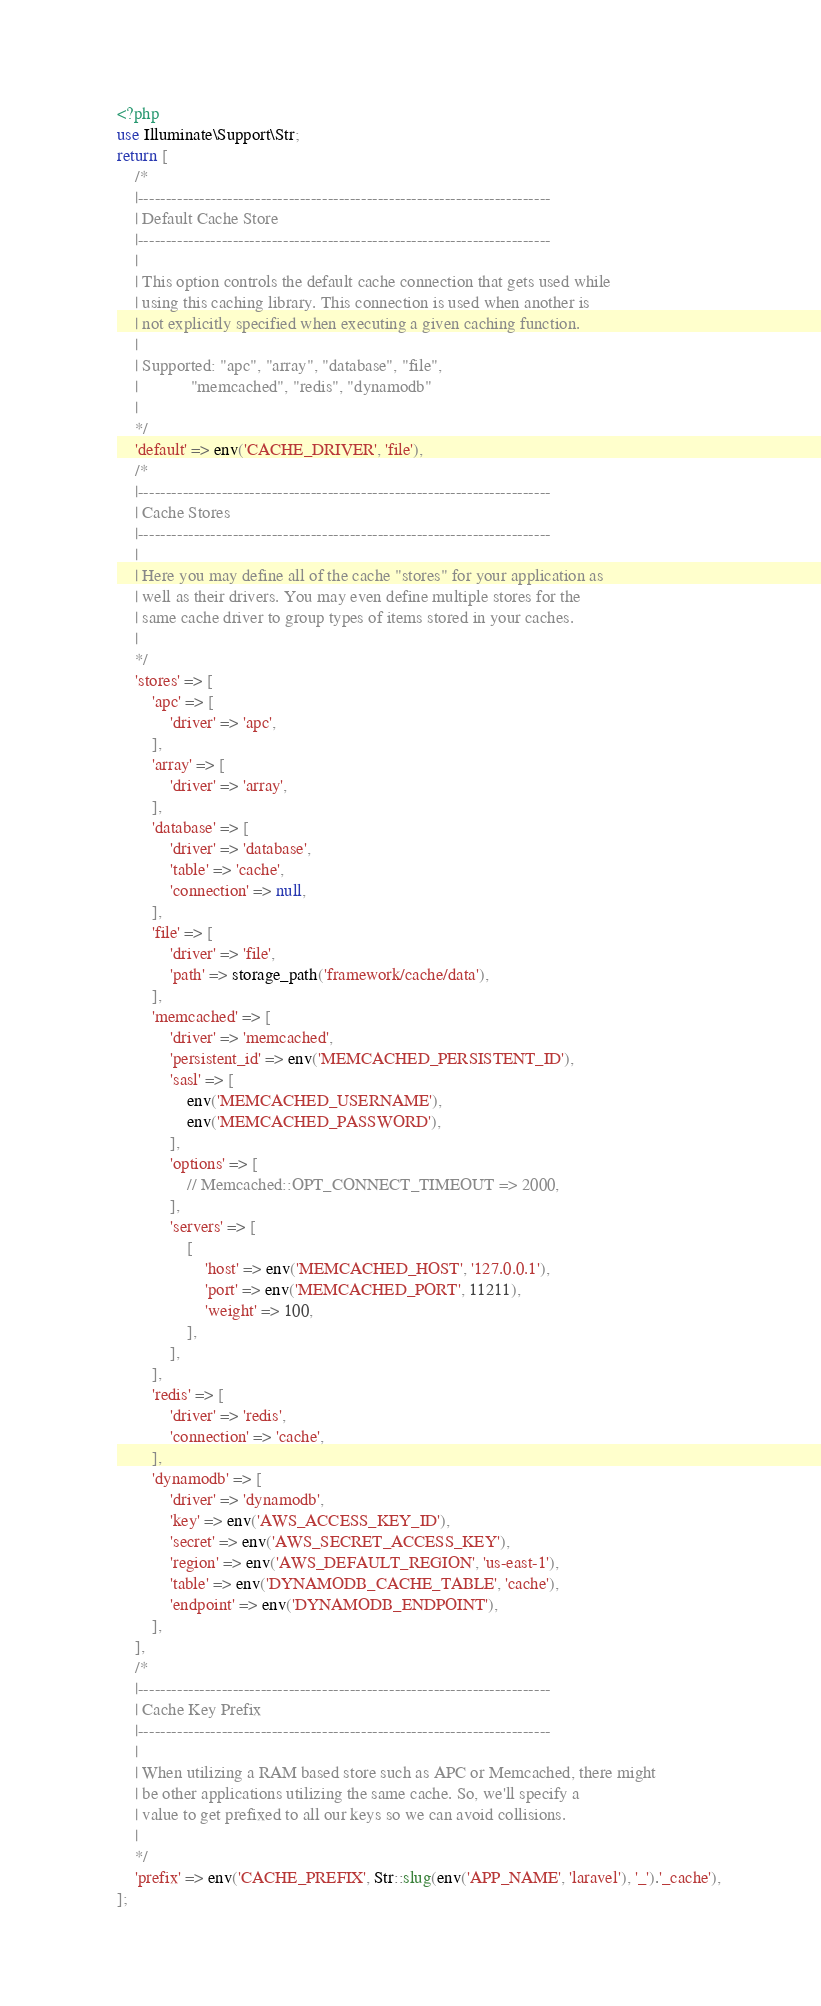Convert code to text. <code><loc_0><loc_0><loc_500><loc_500><_PHP_><?php
use Illuminate\Support\Str;
return [
    /*
    |--------------------------------------------------------------------------
    | Default Cache Store
    |--------------------------------------------------------------------------
    |
    | This option controls the default cache connection that gets used while
    | using this caching library. This connection is used when another is
    | not explicitly specified when executing a given caching function.
    |
    | Supported: "apc", "array", "database", "file",
    |            "memcached", "redis", "dynamodb"
    |
    */
    'default' => env('CACHE_DRIVER', 'file'),
    /*
    |--------------------------------------------------------------------------
    | Cache Stores
    |--------------------------------------------------------------------------
    |
    | Here you may define all of the cache "stores" for your application as
    | well as their drivers. You may even define multiple stores for the
    | same cache driver to group types of items stored in your caches.
    |
    */
    'stores' => [
        'apc' => [
            'driver' => 'apc',
        ],
        'array' => [
            'driver' => 'array',
        ],
        'database' => [
            'driver' => 'database',
            'table' => 'cache',
            'connection' => null,
        ],
        'file' => [
            'driver' => 'file',
            'path' => storage_path('framework/cache/data'),
        ],
        'memcached' => [
            'driver' => 'memcached',
            'persistent_id' => env('MEMCACHED_PERSISTENT_ID'),
            'sasl' => [
                env('MEMCACHED_USERNAME'),
                env('MEMCACHED_PASSWORD'),
            ],
            'options' => [
                // Memcached::OPT_CONNECT_TIMEOUT => 2000,
            ],
            'servers' => [
                [
                    'host' => env('MEMCACHED_HOST', '127.0.0.1'),
                    'port' => env('MEMCACHED_PORT', 11211),
                    'weight' => 100,
                ],
            ],
        ],
        'redis' => [
            'driver' => 'redis',
            'connection' => 'cache',
        ],
        'dynamodb' => [
            'driver' => 'dynamodb',
            'key' => env('AWS_ACCESS_KEY_ID'),
            'secret' => env('AWS_SECRET_ACCESS_KEY'),
            'region' => env('AWS_DEFAULT_REGION', 'us-east-1'),
            'table' => env('DYNAMODB_CACHE_TABLE', 'cache'),
            'endpoint' => env('DYNAMODB_ENDPOINT'),
        ],
    ],
    /*
    |--------------------------------------------------------------------------
    | Cache Key Prefix
    |--------------------------------------------------------------------------
    |
    | When utilizing a RAM based store such as APC or Memcached, there might
    | be other applications utilizing the same cache. So, we'll specify a
    | value to get prefixed to all our keys so we can avoid collisions.
    |
    */
    'prefix' => env('CACHE_PREFIX', Str::slug(env('APP_NAME', 'laravel'), '_').'_cache'),
];
</code> 